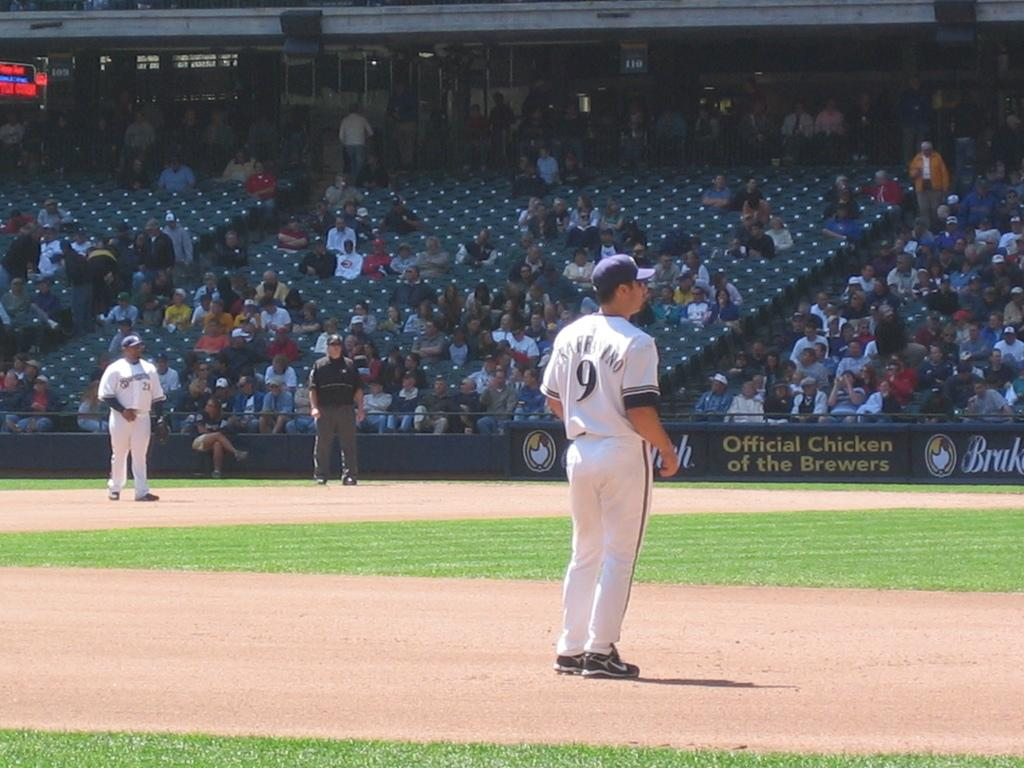Provide a one-sentence caption for the provided image. A logo for the Official Chicken of the Brewers can be seen on the stadium. 